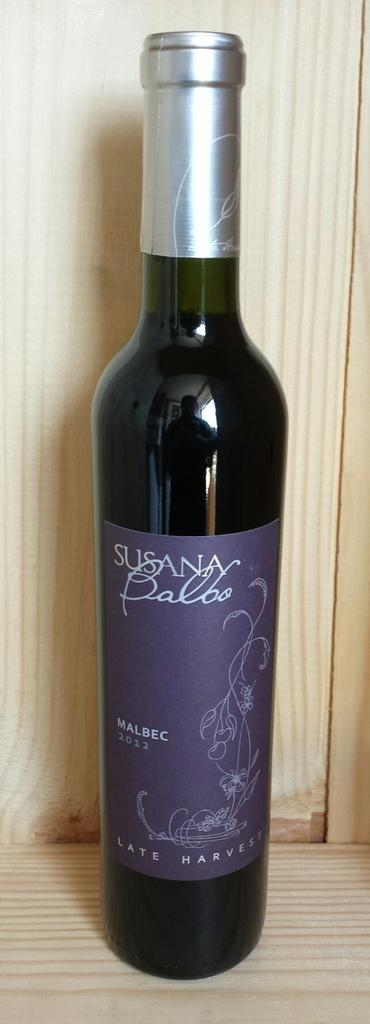Provide a one-sentence caption for the provided image. A bottle of red wine with Susana Balbo written on the label. 